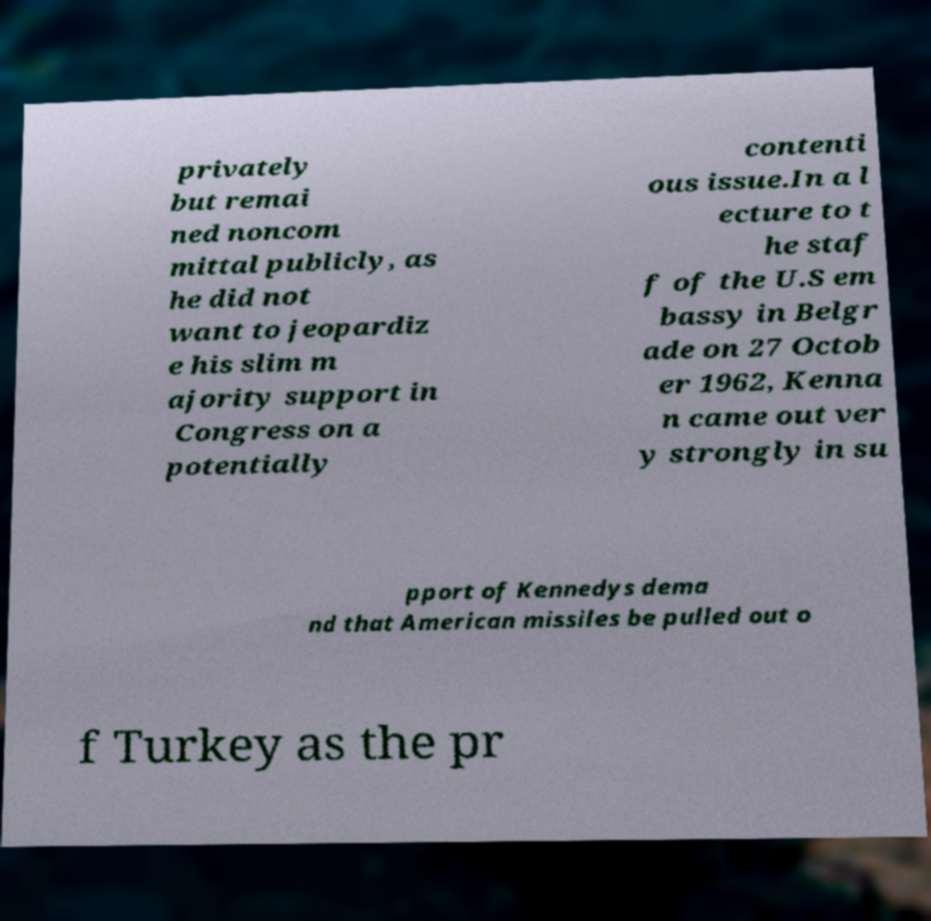Please read and relay the text visible in this image. What does it say? privately but remai ned noncom mittal publicly, as he did not want to jeopardiz e his slim m ajority support in Congress on a potentially contenti ous issue.In a l ecture to t he staf f of the U.S em bassy in Belgr ade on 27 Octob er 1962, Kenna n came out ver y strongly in su pport of Kennedys dema nd that American missiles be pulled out o f Turkey as the pr 